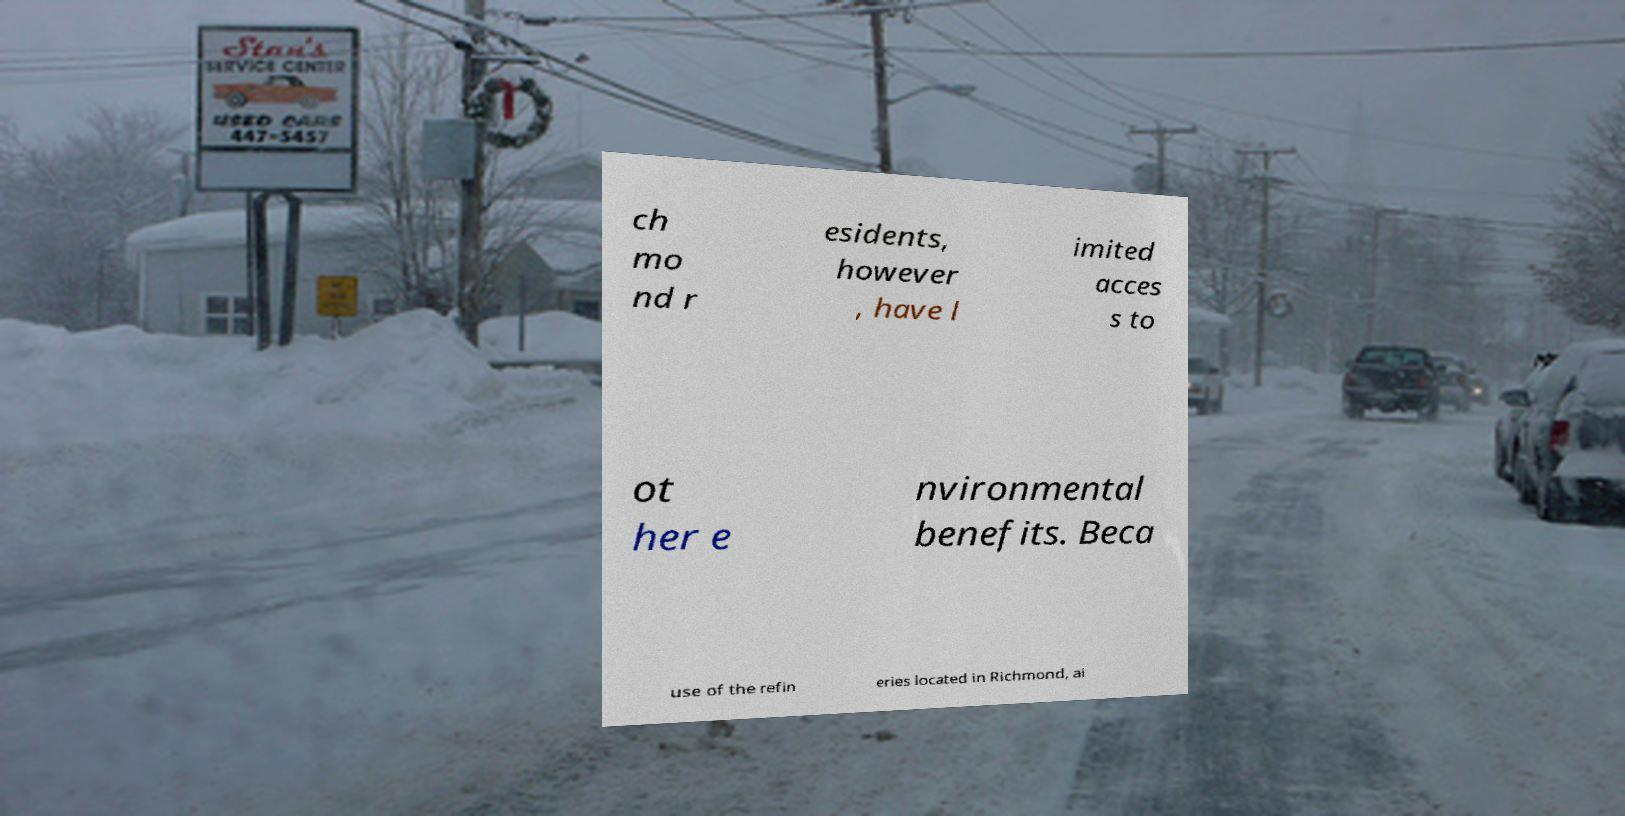Can you accurately transcribe the text from the provided image for me? ch mo nd r esidents, however , have l imited acces s to ot her e nvironmental benefits. Beca use of the refin eries located in Richmond, ai 